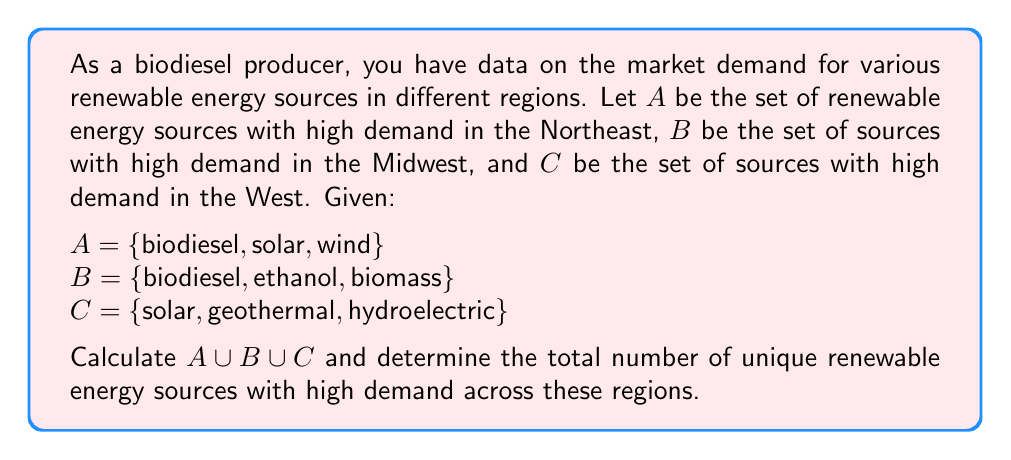Provide a solution to this math problem. To solve this problem, we need to find the union of sets A, B, and C. The union of sets includes all unique elements that appear in any of the sets, without repetition.

Let's break it down step-by-step:

1. First, let's list all the elements in each set:
   A = {biodiesel, solar, wind}
   B = {biodiesel, ethanol, biomass}
   C = {solar, geothermal, hydroelectric}

2. Now, we'll combine all elements from these sets, noting any repetitions:
   A ∪ B ∪ C = {biodiesel, solar, wind, ethanol, biomass, geothermal, hydroelectric}

3. We can see that 'biodiesel' appears in both A and B, and 'solar' appears in both A and C. However, we only include each element once in the union.

4. To calculate the total number of unique renewable energy sources, we simply count the elements in the union:
   |A ∪ B ∪ C| = 7

Therefore, the union of sets A, B, and C contains 7 unique renewable energy sources with high demand across the Northeast, Midwest, and West regions.
Answer: $A \cup B \cup C = \{biodiesel, solar, wind, ethanol, biomass, geothermal, hydroelectric\}$

Total number of unique renewable energy sources: 7 